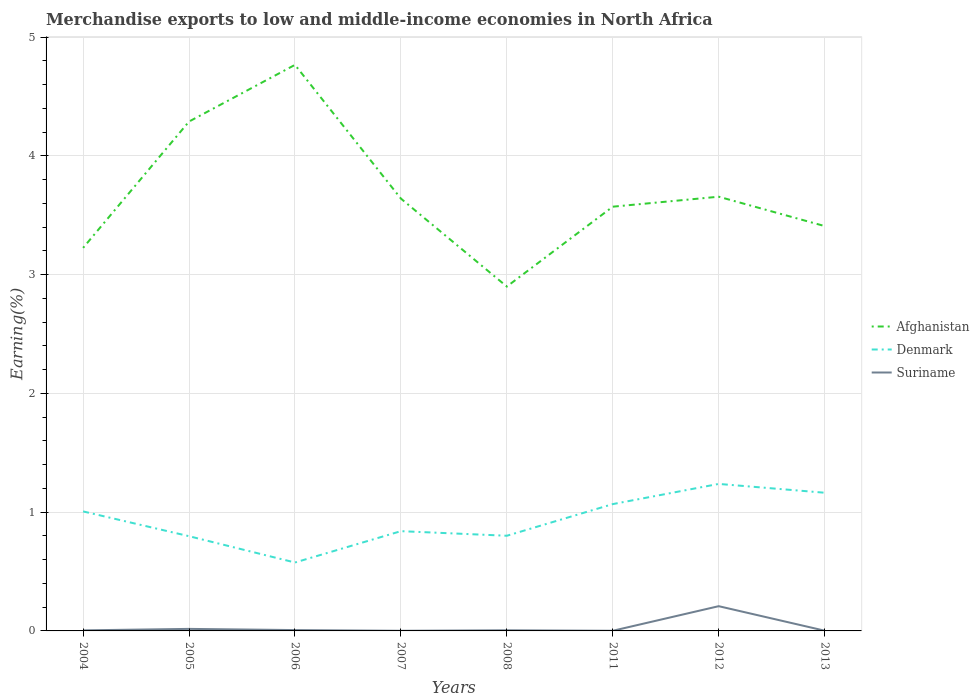Does the line corresponding to Denmark intersect with the line corresponding to Afghanistan?
Your answer should be compact. No. Is the number of lines equal to the number of legend labels?
Your answer should be very brief. Yes. Across all years, what is the maximum percentage of amount earned from merchandise exports in Suriname?
Make the answer very short. 0. In which year was the percentage of amount earned from merchandise exports in Suriname maximum?
Keep it short and to the point. 2007. What is the total percentage of amount earned from merchandise exports in Suriname in the graph?
Ensure brevity in your answer.  -0.2. What is the difference between the highest and the second highest percentage of amount earned from merchandise exports in Afghanistan?
Keep it short and to the point. 1.87. What is the difference between the highest and the lowest percentage of amount earned from merchandise exports in Suriname?
Your response must be concise. 1. How many years are there in the graph?
Ensure brevity in your answer.  8. Does the graph contain grids?
Your answer should be very brief. Yes. Where does the legend appear in the graph?
Your answer should be compact. Center right. How many legend labels are there?
Your answer should be very brief. 3. What is the title of the graph?
Provide a succinct answer. Merchandise exports to low and middle-income economies in North Africa. What is the label or title of the X-axis?
Your response must be concise. Years. What is the label or title of the Y-axis?
Offer a very short reply. Earning(%). What is the Earning(%) in Afghanistan in 2004?
Give a very brief answer. 3.23. What is the Earning(%) in Denmark in 2004?
Provide a succinct answer. 1.01. What is the Earning(%) in Suriname in 2004?
Provide a short and direct response. 0. What is the Earning(%) of Afghanistan in 2005?
Offer a very short reply. 4.29. What is the Earning(%) of Denmark in 2005?
Offer a very short reply. 0.8. What is the Earning(%) in Suriname in 2005?
Your answer should be very brief. 0.02. What is the Earning(%) of Afghanistan in 2006?
Offer a very short reply. 4.77. What is the Earning(%) of Denmark in 2006?
Give a very brief answer. 0.58. What is the Earning(%) in Suriname in 2006?
Your response must be concise. 0.01. What is the Earning(%) of Afghanistan in 2007?
Provide a short and direct response. 3.64. What is the Earning(%) of Denmark in 2007?
Provide a short and direct response. 0.84. What is the Earning(%) in Suriname in 2007?
Give a very brief answer. 0. What is the Earning(%) of Afghanistan in 2008?
Make the answer very short. 2.9. What is the Earning(%) in Denmark in 2008?
Give a very brief answer. 0.8. What is the Earning(%) in Suriname in 2008?
Keep it short and to the point. 0.01. What is the Earning(%) of Afghanistan in 2011?
Give a very brief answer. 3.57. What is the Earning(%) of Denmark in 2011?
Make the answer very short. 1.07. What is the Earning(%) of Suriname in 2011?
Your response must be concise. 0. What is the Earning(%) of Afghanistan in 2012?
Your answer should be compact. 3.66. What is the Earning(%) in Denmark in 2012?
Make the answer very short. 1.24. What is the Earning(%) of Suriname in 2012?
Your answer should be compact. 0.21. What is the Earning(%) in Afghanistan in 2013?
Your answer should be compact. 3.41. What is the Earning(%) in Denmark in 2013?
Ensure brevity in your answer.  1.16. What is the Earning(%) of Suriname in 2013?
Provide a short and direct response. 0. Across all years, what is the maximum Earning(%) in Afghanistan?
Ensure brevity in your answer.  4.77. Across all years, what is the maximum Earning(%) of Denmark?
Keep it short and to the point. 1.24. Across all years, what is the maximum Earning(%) in Suriname?
Provide a succinct answer. 0.21. Across all years, what is the minimum Earning(%) of Afghanistan?
Ensure brevity in your answer.  2.9. Across all years, what is the minimum Earning(%) of Denmark?
Your response must be concise. 0.58. Across all years, what is the minimum Earning(%) in Suriname?
Provide a succinct answer. 0. What is the total Earning(%) in Afghanistan in the graph?
Your response must be concise. 29.46. What is the total Earning(%) of Denmark in the graph?
Offer a very short reply. 7.49. What is the total Earning(%) of Suriname in the graph?
Give a very brief answer. 0.25. What is the difference between the Earning(%) of Afghanistan in 2004 and that in 2005?
Your response must be concise. -1.06. What is the difference between the Earning(%) in Denmark in 2004 and that in 2005?
Ensure brevity in your answer.  0.21. What is the difference between the Earning(%) in Suriname in 2004 and that in 2005?
Offer a very short reply. -0.01. What is the difference between the Earning(%) of Afghanistan in 2004 and that in 2006?
Provide a succinct answer. -1.54. What is the difference between the Earning(%) in Denmark in 2004 and that in 2006?
Your answer should be compact. 0.43. What is the difference between the Earning(%) of Suriname in 2004 and that in 2006?
Provide a short and direct response. -0. What is the difference between the Earning(%) in Afghanistan in 2004 and that in 2007?
Provide a succinct answer. -0.41. What is the difference between the Earning(%) of Denmark in 2004 and that in 2007?
Your answer should be compact. 0.17. What is the difference between the Earning(%) of Suriname in 2004 and that in 2007?
Keep it short and to the point. 0. What is the difference between the Earning(%) in Afghanistan in 2004 and that in 2008?
Make the answer very short. 0.33. What is the difference between the Earning(%) of Denmark in 2004 and that in 2008?
Offer a very short reply. 0.2. What is the difference between the Earning(%) in Suriname in 2004 and that in 2008?
Ensure brevity in your answer.  -0. What is the difference between the Earning(%) of Afghanistan in 2004 and that in 2011?
Your answer should be compact. -0.35. What is the difference between the Earning(%) of Denmark in 2004 and that in 2011?
Keep it short and to the point. -0.06. What is the difference between the Earning(%) in Suriname in 2004 and that in 2011?
Make the answer very short. 0. What is the difference between the Earning(%) in Afghanistan in 2004 and that in 2012?
Offer a very short reply. -0.43. What is the difference between the Earning(%) in Denmark in 2004 and that in 2012?
Give a very brief answer. -0.23. What is the difference between the Earning(%) in Suriname in 2004 and that in 2012?
Provide a short and direct response. -0.2. What is the difference between the Earning(%) of Afghanistan in 2004 and that in 2013?
Make the answer very short. -0.18. What is the difference between the Earning(%) of Denmark in 2004 and that in 2013?
Provide a succinct answer. -0.16. What is the difference between the Earning(%) of Suriname in 2004 and that in 2013?
Make the answer very short. 0. What is the difference between the Earning(%) in Afghanistan in 2005 and that in 2006?
Provide a short and direct response. -0.48. What is the difference between the Earning(%) in Denmark in 2005 and that in 2006?
Your answer should be compact. 0.22. What is the difference between the Earning(%) in Suriname in 2005 and that in 2006?
Make the answer very short. 0.01. What is the difference between the Earning(%) in Afghanistan in 2005 and that in 2007?
Offer a very short reply. 0.65. What is the difference between the Earning(%) in Denmark in 2005 and that in 2007?
Ensure brevity in your answer.  -0.04. What is the difference between the Earning(%) of Suriname in 2005 and that in 2007?
Give a very brief answer. 0.02. What is the difference between the Earning(%) of Afghanistan in 2005 and that in 2008?
Offer a very short reply. 1.39. What is the difference between the Earning(%) in Denmark in 2005 and that in 2008?
Provide a short and direct response. -0. What is the difference between the Earning(%) of Suriname in 2005 and that in 2008?
Keep it short and to the point. 0.01. What is the difference between the Earning(%) in Afghanistan in 2005 and that in 2011?
Your answer should be compact. 0.72. What is the difference between the Earning(%) in Denmark in 2005 and that in 2011?
Keep it short and to the point. -0.27. What is the difference between the Earning(%) in Suriname in 2005 and that in 2011?
Provide a succinct answer. 0.02. What is the difference between the Earning(%) in Afghanistan in 2005 and that in 2012?
Offer a terse response. 0.63. What is the difference between the Earning(%) of Denmark in 2005 and that in 2012?
Your response must be concise. -0.44. What is the difference between the Earning(%) of Suriname in 2005 and that in 2012?
Offer a terse response. -0.19. What is the difference between the Earning(%) in Afghanistan in 2005 and that in 2013?
Provide a short and direct response. 0.88. What is the difference between the Earning(%) in Denmark in 2005 and that in 2013?
Your answer should be compact. -0.37. What is the difference between the Earning(%) in Suriname in 2005 and that in 2013?
Ensure brevity in your answer.  0.01. What is the difference between the Earning(%) in Afghanistan in 2006 and that in 2007?
Provide a short and direct response. 1.13. What is the difference between the Earning(%) in Denmark in 2006 and that in 2007?
Give a very brief answer. -0.26. What is the difference between the Earning(%) in Suriname in 2006 and that in 2007?
Give a very brief answer. 0.01. What is the difference between the Earning(%) of Afghanistan in 2006 and that in 2008?
Keep it short and to the point. 1.87. What is the difference between the Earning(%) in Denmark in 2006 and that in 2008?
Ensure brevity in your answer.  -0.23. What is the difference between the Earning(%) of Suriname in 2006 and that in 2008?
Provide a short and direct response. 0. What is the difference between the Earning(%) in Afghanistan in 2006 and that in 2011?
Offer a very short reply. 1.19. What is the difference between the Earning(%) of Denmark in 2006 and that in 2011?
Provide a short and direct response. -0.49. What is the difference between the Earning(%) in Suriname in 2006 and that in 2011?
Ensure brevity in your answer.  0.01. What is the difference between the Earning(%) of Afghanistan in 2006 and that in 2012?
Your response must be concise. 1.11. What is the difference between the Earning(%) of Denmark in 2006 and that in 2012?
Give a very brief answer. -0.66. What is the difference between the Earning(%) of Suriname in 2006 and that in 2012?
Ensure brevity in your answer.  -0.2. What is the difference between the Earning(%) of Afghanistan in 2006 and that in 2013?
Offer a very short reply. 1.36. What is the difference between the Earning(%) of Denmark in 2006 and that in 2013?
Ensure brevity in your answer.  -0.59. What is the difference between the Earning(%) in Suriname in 2006 and that in 2013?
Provide a succinct answer. 0.01. What is the difference between the Earning(%) in Afghanistan in 2007 and that in 2008?
Offer a terse response. 0.74. What is the difference between the Earning(%) of Denmark in 2007 and that in 2008?
Give a very brief answer. 0.04. What is the difference between the Earning(%) in Suriname in 2007 and that in 2008?
Keep it short and to the point. -0. What is the difference between the Earning(%) of Afghanistan in 2007 and that in 2011?
Offer a terse response. 0.07. What is the difference between the Earning(%) in Denmark in 2007 and that in 2011?
Your answer should be very brief. -0.23. What is the difference between the Earning(%) in Suriname in 2007 and that in 2011?
Provide a short and direct response. -0. What is the difference between the Earning(%) of Afghanistan in 2007 and that in 2012?
Your answer should be compact. -0.02. What is the difference between the Earning(%) in Denmark in 2007 and that in 2012?
Keep it short and to the point. -0.4. What is the difference between the Earning(%) of Suriname in 2007 and that in 2012?
Make the answer very short. -0.21. What is the difference between the Earning(%) in Afghanistan in 2007 and that in 2013?
Offer a terse response. 0.23. What is the difference between the Earning(%) of Denmark in 2007 and that in 2013?
Provide a short and direct response. -0.32. What is the difference between the Earning(%) of Suriname in 2007 and that in 2013?
Ensure brevity in your answer.  -0. What is the difference between the Earning(%) in Afghanistan in 2008 and that in 2011?
Offer a terse response. -0.67. What is the difference between the Earning(%) in Denmark in 2008 and that in 2011?
Offer a terse response. -0.27. What is the difference between the Earning(%) of Suriname in 2008 and that in 2011?
Your answer should be very brief. 0. What is the difference between the Earning(%) of Afghanistan in 2008 and that in 2012?
Offer a very short reply. -0.76. What is the difference between the Earning(%) in Denmark in 2008 and that in 2012?
Offer a very short reply. -0.44. What is the difference between the Earning(%) in Suriname in 2008 and that in 2012?
Give a very brief answer. -0.2. What is the difference between the Earning(%) of Afghanistan in 2008 and that in 2013?
Your answer should be very brief. -0.51. What is the difference between the Earning(%) in Denmark in 2008 and that in 2013?
Offer a very short reply. -0.36. What is the difference between the Earning(%) in Suriname in 2008 and that in 2013?
Make the answer very short. 0. What is the difference between the Earning(%) of Afghanistan in 2011 and that in 2012?
Give a very brief answer. -0.08. What is the difference between the Earning(%) of Denmark in 2011 and that in 2012?
Your response must be concise. -0.17. What is the difference between the Earning(%) of Suriname in 2011 and that in 2012?
Ensure brevity in your answer.  -0.21. What is the difference between the Earning(%) in Afghanistan in 2011 and that in 2013?
Offer a terse response. 0.16. What is the difference between the Earning(%) of Denmark in 2011 and that in 2013?
Ensure brevity in your answer.  -0.1. What is the difference between the Earning(%) in Suriname in 2011 and that in 2013?
Offer a very short reply. -0. What is the difference between the Earning(%) of Afghanistan in 2012 and that in 2013?
Your answer should be very brief. 0.25. What is the difference between the Earning(%) of Denmark in 2012 and that in 2013?
Ensure brevity in your answer.  0.07. What is the difference between the Earning(%) in Suriname in 2012 and that in 2013?
Give a very brief answer. 0.21. What is the difference between the Earning(%) of Afghanistan in 2004 and the Earning(%) of Denmark in 2005?
Offer a terse response. 2.43. What is the difference between the Earning(%) in Afghanistan in 2004 and the Earning(%) in Suriname in 2005?
Your response must be concise. 3.21. What is the difference between the Earning(%) in Afghanistan in 2004 and the Earning(%) in Denmark in 2006?
Your answer should be compact. 2.65. What is the difference between the Earning(%) of Afghanistan in 2004 and the Earning(%) of Suriname in 2006?
Your answer should be compact. 3.22. What is the difference between the Earning(%) of Afghanistan in 2004 and the Earning(%) of Denmark in 2007?
Offer a terse response. 2.39. What is the difference between the Earning(%) in Afghanistan in 2004 and the Earning(%) in Suriname in 2007?
Provide a succinct answer. 3.22. What is the difference between the Earning(%) of Denmark in 2004 and the Earning(%) of Suriname in 2007?
Your answer should be very brief. 1.01. What is the difference between the Earning(%) of Afghanistan in 2004 and the Earning(%) of Denmark in 2008?
Offer a terse response. 2.42. What is the difference between the Earning(%) in Afghanistan in 2004 and the Earning(%) in Suriname in 2008?
Make the answer very short. 3.22. What is the difference between the Earning(%) of Denmark in 2004 and the Earning(%) of Suriname in 2008?
Give a very brief answer. 1. What is the difference between the Earning(%) of Afghanistan in 2004 and the Earning(%) of Denmark in 2011?
Your answer should be very brief. 2.16. What is the difference between the Earning(%) of Afghanistan in 2004 and the Earning(%) of Suriname in 2011?
Your answer should be compact. 3.22. What is the difference between the Earning(%) in Denmark in 2004 and the Earning(%) in Suriname in 2011?
Provide a succinct answer. 1. What is the difference between the Earning(%) of Afghanistan in 2004 and the Earning(%) of Denmark in 2012?
Provide a succinct answer. 1.99. What is the difference between the Earning(%) of Afghanistan in 2004 and the Earning(%) of Suriname in 2012?
Ensure brevity in your answer.  3.02. What is the difference between the Earning(%) of Denmark in 2004 and the Earning(%) of Suriname in 2012?
Offer a terse response. 0.8. What is the difference between the Earning(%) of Afghanistan in 2004 and the Earning(%) of Denmark in 2013?
Provide a short and direct response. 2.06. What is the difference between the Earning(%) of Afghanistan in 2004 and the Earning(%) of Suriname in 2013?
Your answer should be compact. 3.22. What is the difference between the Earning(%) of Denmark in 2004 and the Earning(%) of Suriname in 2013?
Your response must be concise. 1. What is the difference between the Earning(%) in Afghanistan in 2005 and the Earning(%) in Denmark in 2006?
Offer a terse response. 3.71. What is the difference between the Earning(%) in Afghanistan in 2005 and the Earning(%) in Suriname in 2006?
Make the answer very short. 4.28. What is the difference between the Earning(%) in Denmark in 2005 and the Earning(%) in Suriname in 2006?
Offer a very short reply. 0.79. What is the difference between the Earning(%) in Afghanistan in 2005 and the Earning(%) in Denmark in 2007?
Your answer should be compact. 3.45. What is the difference between the Earning(%) of Afghanistan in 2005 and the Earning(%) of Suriname in 2007?
Provide a succinct answer. 4.29. What is the difference between the Earning(%) in Denmark in 2005 and the Earning(%) in Suriname in 2007?
Ensure brevity in your answer.  0.8. What is the difference between the Earning(%) of Afghanistan in 2005 and the Earning(%) of Denmark in 2008?
Offer a terse response. 3.49. What is the difference between the Earning(%) of Afghanistan in 2005 and the Earning(%) of Suriname in 2008?
Your answer should be compact. 4.28. What is the difference between the Earning(%) of Denmark in 2005 and the Earning(%) of Suriname in 2008?
Your answer should be very brief. 0.79. What is the difference between the Earning(%) of Afghanistan in 2005 and the Earning(%) of Denmark in 2011?
Give a very brief answer. 3.22. What is the difference between the Earning(%) of Afghanistan in 2005 and the Earning(%) of Suriname in 2011?
Your answer should be compact. 4.29. What is the difference between the Earning(%) in Denmark in 2005 and the Earning(%) in Suriname in 2011?
Provide a short and direct response. 0.8. What is the difference between the Earning(%) of Afghanistan in 2005 and the Earning(%) of Denmark in 2012?
Offer a very short reply. 3.05. What is the difference between the Earning(%) of Afghanistan in 2005 and the Earning(%) of Suriname in 2012?
Keep it short and to the point. 4.08. What is the difference between the Earning(%) in Denmark in 2005 and the Earning(%) in Suriname in 2012?
Ensure brevity in your answer.  0.59. What is the difference between the Earning(%) of Afghanistan in 2005 and the Earning(%) of Denmark in 2013?
Your answer should be very brief. 3.13. What is the difference between the Earning(%) of Afghanistan in 2005 and the Earning(%) of Suriname in 2013?
Give a very brief answer. 4.29. What is the difference between the Earning(%) in Denmark in 2005 and the Earning(%) in Suriname in 2013?
Offer a very short reply. 0.8. What is the difference between the Earning(%) of Afghanistan in 2006 and the Earning(%) of Denmark in 2007?
Your answer should be very brief. 3.93. What is the difference between the Earning(%) in Afghanistan in 2006 and the Earning(%) in Suriname in 2007?
Keep it short and to the point. 4.76. What is the difference between the Earning(%) of Denmark in 2006 and the Earning(%) of Suriname in 2007?
Your response must be concise. 0.57. What is the difference between the Earning(%) in Afghanistan in 2006 and the Earning(%) in Denmark in 2008?
Provide a succinct answer. 3.96. What is the difference between the Earning(%) of Afghanistan in 2006 and the Earning(%) of Suriname in 2008?
Your answer should be very brief. 4.76. What is the difference between the Earning(%) in Denmark in 2006 and the Earning(%) in Suriname in 2008?
Your response must be concise. 0.57. What is the difference between the Earning(%) in Afghanistan in 2006 and the Earning(%) in Denmark in 2011?
Your answer should be compact. 3.7. What is the difference between the Earning(%) in Afghanistan in 2006 and the Earning(%) in Suriname in 2011?
Your answer should be very brief. 4.76. What is the difference between the Earning(%) of Denmark in 2006 and the Earning(%) of Suriname in 2011?
Provide a short and direct response. 0.57. What is the difference between the Earning(%) of Afghanistan in 2006 and the Earning(%) of Denmark in 2012?
Offer a terse response. 3.53. What is the difference between the Earning(%) in Afghanistan in 2006 and the Earning(%) in Suriname in 2012?
Make the answer very short. 4.56. What is the difference between the Earning(%) of Denmark in 2006 and the Earning(%) of Suriname in 2012?
Give a very brief answer. 0.37. What is the difference between the Earning(%) in Afghanistan in 2006 and the Earning(%) in Denmark in 2013?
Your response must be concise. 3.6. What is the difference between the Earning(%) of Afghanistan in 2006 and the Earning(%) of Suriname in 2013?
Your answer should be very brief. 4.76. What is the difference between the Earning(%) of Denmark in 2006 and the Earning(%) of Suriname in 2013?
Give a very brief answer. 0.57. What is the difference between the Earning(%) in Afghanistan in 2007 and the Earning(%) in Denmark in 2008?
Your response must be concise. 2.84. What is the difference between the Earning(%) of Afghanistan in 2007 and the Earning(%) of Suriname in 2008?
Make the answer very short. 3.63. What is the difference between the Earning(%) in Denmark in 2007 and the Earning(%) in Suriname in 2008?
Provide a short and direct response. 0.83. What is the difference between the Earning(%) in Afghanistan in 2007 and the Earning(%) in Denmark in 2011?
Your response must be concise. 2.57. What is the difference between the Earning(%) in Afghanistan in 2007 and the Earning(%) in Suriname in 2011?
Your answer should be compact. 3.64. What is the difference between the Earning(%) of Denmark in 2007 and the Earning(%) of Suriname in 2011?
Your answer should be compact. 0.84. What is the difference between the Earning(%) in Afghanistan in 2007 and the Earning(%) in Denmark in 2012?
Your answer should be compact. 2.4. What is the difference between the Earning(%) in Afghanistan in 2007 and the Earning(%) in Suriname in 2012?
Ensure brevity in your answer.  3.43. What is the difference between the Earning(%) of Denmark in 2007 and the Earning(%) of Suriname in 2012?
Give a very brief answer. 0.63. What is the difference between the Earning(%) of Afghanistan in 2007 and the Earning(%) of Denmark in 2013?
Keep it short and to the point. 2.48. What is the difference between the Earning(%) of Afghanistan in 2007 and the Earning(%) of Suriname in 2013?
Make the answer very short. 3.64. What is the difference between the Earning(%) of Denmark in 2007 and the Earning(%) of Suriname in 2013?
Offer a very short reply. 0.84. What is the difference between the Earning(%) of Afghanistan in 2008 and the Earning(%) of Denmark in 2011?
Ensure brevity in your answer.  1.83. What is the difference between the Earning(%) of Afghanistan in 2008 and the Earning(%) of Suriname in 2011?
Provide a succinct answer. 2.9. What is the difference between the Earning(%) in Denmark in 2008 and the Earning(%) in Suriname in 2011?
Your answer should be compact. 0.8. What is the difference between the Earning(%) of Afghanistan in 2008 and the Earning(%) of Denmark in 2012?
Your answer should be compact. 1.66. What is the difference between the Earning(%) in Afghanistan in 2008 and the Earning(%) in Suriname in 2012?
Your answer should be compact. 2.69. What is the difference between the Earning(%) in Denmark in 2008 and the Earning(%) in Suriname in 2012?
Offer a terse response. 0.59. What is the difference between the Earning(%) in Afghanistan in 2008 and the Earning(%) in Denmark in 2013?
Offer a terse response. 1.74. What is the difference between the Earning(%) in Afghanistan in 2008 and the Earning(%) in Suriname in 2013?
Your answer should be compact. 2.9. What is the difference between the Earning(%) in Denmark in 2008 and the Earning(%) in Suriname in 2013?
Keep it short and to the point. 0.8. What is the difference between the Earning(%) of Afghanistan in 2011 and the Earning(%) of Denmark in 2012?
Ensure brevity in your answer.  2.33. What is the difference between the Earning(%) in Afghanistan in 2011 and the Earning(%) in Suriname in 2012?
Offer a terse response. 3.36. What is the difference between the Earning(%) in Denmark in 2011 and the Earning(%) in Suriname in 2012?
Your answer should be very brief. 0.86. What is the difference between the Earning(%) in Afghanistan in 2011 and the Earning(%) in Denmark in 2013?
Make the answer very short. 2.41. What is the difference between the Earning(%) in Afghanistan in 2011 and the Earning(%) in Suriname in 2013?
Your answer should be very brief. 3.57. What is the difference between the Earning(%) in Denmark in 2011 and the Earning(%) in Suriname in 2013?
Give a very brief answer. 1.07. What is the difference between the Earning(%) of Afghanistan in 2012 and the Earning(%) of Denmark in 2013?
Make the answer very short. 2.49. What is the difference between the Earning(%) of Afghanistan in 2012 and the Earning(%) of Suriname in 2013?
Make the answer very short. 3.65. What is the difference between the Earning(%) of Denmark in 2012 and the Earning(%) of Suriname in 2013?
Provide a short and direct response. 1.24. What is the average Earning(%) of Afghanistan per year?
Offer a terse response. 3.68. What is the average Earning(%) of Denmark per year?
Ensure brevity in your answer.  0.94. What is the average Earning(%) in Suriname per year?
Provide a short and direct response. 0.03. In the year 2004, what is the difference between the Earning(%) of Afghanistan and Earning(%) of Denmark?
Your answer should be very brief. 2.22. In the year 2004, what is the difference between the Earning(%) in Afghanistan and Earning(%) in Suriname?
Offer a very short reply. 3.22. In the year 2005, what is the difference between the Earning(%) of Afghanistan and Earning(%) of Denmark?
Ensure brevity in your answer.  3.49. In the year 2005, what is the difference between the Earning(%) in Afghanistan and Earning(%) in Suriname?
Keep it short and to the point. 4.27. In the year 2005, what is the difference between the Earning(%) of Denmark and Earning(%) of Suriname?
Offer a terse response. 0.78. In the year 2006, what is the difference between the Earning(%) of Afghanistan and Earning(%) of Denmark?
Keep it short and to the point. 4.19. In the year 2006, what is the difference between the Earning(%) in Afghanistan and Earning(%) in Suriname?
Your response must be concise. 4.76. In the year 2006, what is the difference between the Earning(%) of Denmark and Earning(%) of Suriname?
Make the answer very short. 0.57. In the year 2007, what is the difference between the Earning(%) in Afghanistan and Earning(%) in Denmark?
Your answer should be compact. 2.8. In the year 2007, what is the difference between the Earning(%) of Afghanistan and Earning(%) of Suriname?
Your answer should be very brief. 3.64. In the year 2007, what is the difference between the Earning(%) in Denmark and Earning(%) in Suriname?
Your answer should be very brief. 0.84. In the year 2008, what is the difference between the Earning(%) of Afghanistan and Earning(%) of Denmark?
Give a very brief answer. 2.1. In the year 2008, what is the difference between the Earning(%) of Afghanistan and Earning(%) of Suriname?
Offer a very short reply. 2.89. In the year 2008, what is the difference between the Earning(%) of Denmark and Earning(%) of Suriname?
Offer a very short reply. 0.8. In the year 2011, what is the difference between the Earning(%) in Afghanistan and Earning(%) in Denmark?
Ensure brevity in your answer.  2.5. In the year 2011, what is the difference between the Earning(%) of Afghanistan and Earning(%) of Suriname?
Your answer should be very brief. 3.57. In the year 2011, what is the difference between the Earning(%) of Denmark and Earning(%) of Suriname?
Your response must be concise. 1.07. In the year 2012, what is the difference between the Earning(%) of Afghanistan and Earning(%) of Denmark?
Ensure brevity in your answer.  2.42. In the year 2012, what is the difference between the Earning(%) in Afghanistan and Earning(%) in Suriname?
Provide a succinct answer. 3.45. In the year 2012, what is the difference between the Earning(%) of Denmark and Earning(%) of Suriname?
Make the answer very short. 1.03. In the year 2013, what is the difference between the Earning(%) in Afghanistan and Earning(%) in Denmark?
Your answer should be compact. 2.25. In the year 2013, what is the difference between the Earning(%) in Afghanistan and Earning(%) in Suriname?
Provide a short and direct response. 3.41. In the year 2013, what is the difference between the Earning(%) of Denmark and Earning(%) of Suriname?
Your answer should be very brief. 1.16. What is the ratio of the Earning(%) of Afghanistan in 2004 to that in 2005?
Offer a terse response. 0.75. What is the ratio of the Earning(%) of Denmark in 2004 to that in 2005?
Ensure brevity in your answer.  1.26. What is the ratio of the Earning(%) of Suriname in 2004 to that in 2005?
Offer a very short reply. 0.27. What is the ratio of the Earning(%) in Afghanistan in 2004 to that in 2006?
Keep it short and to the point. 0.68. What is the ratio of the Earning(%) of Denmark in 2004 to that in 2006?
Your answer should be compact. 1.75. What is the ratio of the Earning(%) of Suriname in 2004 to that in 2006?
Make the answer very short. 0.66. What is the ratio of the Earning(%) in Afghanistan in 2004 to that in 2007?
Provide a short and direct response. 0.89. What is the ratio of the Earning(%) in Denmark in 2004 to that in 2007?
Offer a very short reply. 1.2. What is the ratio of the Earning(%) of Suriname in 2004 to that in 2007?
Provide a short and direct response. 4.11. What is the ratio of the Earning(%) of Afghanistan in 2004 to that in 2008?
Provide a succinct answer. 1.11. What is the ratio of the Earning(%) of Denmark in 2004 to that in 2008?
Make the answer very short. 1.26. What is the ratio of the Earning(%) in Suriname in 2004 to that in 2008?
Provide a succinct answer. 0.87. What is the ratio of the Earning(%) of Afghanistan in 2004 to that in 2011?
Your answer should be compact. 0.9. What is the ratio of the Earning(%) in Denmark in 2004 to that in 2011?
Offer a terse response. 0.94. What is the ratio of the Earning(%) in Suriname in 2004 to that in 2011?
Ensure brevity in your answer.  3.74. What is the ratio of the Earning(%) of Afghanistan in 2004 to that in 2012?
Provide a succinct answer. 0.88. What is the ratio of the Earning(%) in Denmark in 2004 to that in 2012?
Ensure brevity in your answer.  0.81. What is the ratio of the Earning(%) in Suriname in 2004 to that in 2012?
Provide a succinct answer. 0.02. What is the ratio of the Earning(%) of Afghanistan in 2004 to that in 2013?
Offer a terse response. 0.95. What is the ratio of the Earning(%) of Denmark in 2004 to that in 2013?
Provide a short and direct response. 0.86. What is the ratio of the Earning(%) in Suriname in 2004 to that in 2013?
Offer a very short reply. 2.22. What is the ratio of the Earning(%) in Afghanistan in 2005 to that in 2006?
Your answer should be very brief. 0.9. What is the ratio of the Earning(%) of Denmark in 2005 to that in 2006?
Provide a short and direct response. 1.38. What is the ratio of the Earning(%) in Suriname in 2005 to that in 2006?
Offer a terse response. 2.43. What is the ratio of the Earning(%) of Afghanistan in 2005 to that in 2007?
Give a very brief answer. 1.18. What is the ratio of the Earning(%) in Denmark in 2005 to that in 2007?
Ensure brevity in your answer.  0.95. What is the ratio of the Earning(%) in Suriname in 2005 to that in 2007?
Provide a short and direct response. 15.05. What is the ratio of the Earning(%) in Afghanistan in 2005 to that in 2008?
Give a very brief answer. 1.48. What is the ratio of the Earning(%) in Denmark in 2005 to that in 2008?
Offer a terse response. 1. What is the ratio of the Earning(%) in Suriname in 2005 to that in 2008?
Give a very brief answer. 3.19. What is the ratio of the Earning(%) in Afghanistan in 2005 to that in 2011?
Your answer should be very brief. 1.2. What is the ratio of the Earning(%) of Denmark in 2005 to that in 2011?
Your answer should be compact. 0.75. What is the ratio of the Earning(%) of Suriname in 2005 to that in 2011?
Your answer should be compact. 13.7. What is the ratio of the Earning(%) of Afghanistan in 2005 to that in 2012?
Make the answer very short. 1.17. What is the ratio of the Earning(%) in Denmark in 2005 to that in 2012?
Your answer should be compact. 0.64. What is the ratio of the Earning(%) in Suriname in 2005 to that in 2012?
Offer a very short reply. 0.08. What is the ratio of the Earning(%) of Afghanistan in 2005 to that in 2013?
Offer a very short reply. 1.26. What is the ratio of the Earning(%) in Denmark in 2005 to that in 2013?
Provide a short and direct response. 0.69. What is the ratio of the Earning(%) of Suriname in 2005 to that in 2013?
Make the answer very short. 8.13. What is the ratio of the Earning(%) of Afghanistan in 2006 to that in 2007?
Offer a very short reply. 1.31. What is the ratio of the Earning(%) in Denmark in 2006 to that in 2007?
Give a very brief answer. 0.69. What is the ratio of the Earning(%) of Suriname in 2006 to that in 2007?
Your answer should be very brief. 6.2. What is the ratio of the Earning(%) of Afghanistan in 2006 to that in 2008?
Your response must be concise. 1.64. What is the ratio of the Earning(%) of Denmark in 2006 to that in 2008?
Give a very brief answer. 0.72. What is the ratio of the Earning(%) in Suriname in 2006 to that in 2008?
Ensure brevity in your answer.  1.32. What is the ratio of the Earning(%) in Afghanistan in 2006 to that in 2011?
Your response must be concise. 1.33. What is the ratio of the Earning(%) of Denmark in 2006 to that in 2011?
Provide a short and direct response. 0.54. What is the ratio of the Earning(%) of Suriname in 2006 to that in 2011?
Ensure brevity in your answer.  5.65. What is the ratio of the Earning(%) of Afghanistan in 2006 to that in 2012?
Keep it short and to the point. 1.3. What is the ratio of the Earning(%) of Denmark in 2006 to that in 2012?
Provide a short and direct response. 0.47. What is the ratio of the Earning(%) in Suriname in 2006 to that in 2012?
Give a very brief answer. 0.03. What is the ratio of the Earning(%) in Afghanistan in 2006 to that in 2013?
Provide a succinct answer. 1.4. What is the ratio of the Earning(%) in Denmark in 2006 to that in 2013?
Keep it short and to the point. 0.5. What is the ratio of the Earning(%) of Suriname in 2006 to that in 2013?
Your response must be concise. 3.35. What is the ratio of the Earning(%) of Afghanistan in 2007 to that in 2008?
Offer a terse response. 1.26. What is the ratio of the Earning(%) in Denmark in 2007 to that in 2008?
Ensure brevity in your answer.  1.05. What is the ratio of the Earning(%) of Suriname in 2007 to that in 2008?
Keep it short and to the point. 0.21. What is the ratio of the Earning(%) in Afghanistan in 2007 to that in 2011?
Offer a very short reply. 1.02. What is the ratio of the Earning(%) of Denmark in 2007 to that in 2011?
Ensure brevity in your answer.  0.79. What is the ratio of the Earning(%) of Suriname in 2007 to that in 2011?
Offer a very short reply. 0.91. What is the ratio of the Earning(%) in Denmark in 2007 to that in 2012?
Provide a succinct answer. 0.68. What is the ratio of the Earning(%) in Suriname in 2007 to that in 2012?
Make the answer very short. 0.01. What is the ratio of the Earning(%) in Afghanistan in 2007 to that in 2013?
Offer a very short reply. 1.07. What is the ratio of the Earning(%) of Denmark in 2007 to that in 2013?
Your answer should be compact. 0.72. What is the ratio of the Earning(%) of Suriname in 2007 to that in 2013?
Keep it short and to the point. 0.54. What is the ratio of the Earning(%) in Afghanistan in 2008 to that in 2011?
Make the answer very short. 0.81. What is the ratio of the Earning(%) of Denmark in 2008 to that in 2011?
Offer a terse response. 0.75. What is the ratio of the Earning(%) in Suriname in 2008 to that in 2011?
Offer a very short reply. 4.3. What is the ratio of the Earning(%) of Afghanistan in 2008 to that in 2012?
Make the answer very short. 0.79. What is the ratio of the Earning(%) of Denmark in 2008 to that in 2012?
Keep it short and to the point. 0.65. What is the ratio of the Earning(%) of Suriname in 2008 to that in 2012?
Give a very brief answer. 0.03. What is the ratio of the Earning(%) in Afghanistan in 2008 to that in 2013?
Make the answer very short. 0.85. What is the ratio of the Earning(%) of Denmark in 2008 to that in 2013?
Provide a succinct answer. 0.69. What is the ratio of the Earning(%) in Suriname in 2008 to that in 2013?
Provide a succinct answer. 2.55. What is the ratio of the Earning(%) of Afghanistan in 2011 to that in 2012?
Provide a succinct answer. 0.98. What is the ratio of the Earning(%) in Denmark in 2011 to that in 2012?
Provide a succinct answer. 0.86. What is the ratio of the Earning(%) of Suriname in 2011 to that in 2012?
Your answer should be very brief. 0.01. What is the ratio of the Earning(%) in Afghanistan in 2011 to that in 2013?
Give a very brief answer. 1.05. What is the ratio of the Earning(%) in Denmark in 2011 to that in 2013?
Keep it short and to the point. 0.92. What is the ratio of the Earning(%) of Suriname in 2011 to that in 2013?
Your answer should be compact. 0.59. What is the ratio of the Earning(%) of Afghanistan in 2012 to that in 2013?
Your answer should be very brief. 1.07. What is the ratio of the Earning(%) of Denmark in 2012 to that in 2013?
Provide a short and direct response. 1.06. What is the ratio of the Earning(%) in Suriname in 2012 to that in 2013?
Your answer should be very brief. 98.75. What is the difference between the highest and the second highest Earning(%) in Afghanistan?
Your response must be concise. 0.48. What is the difference between the highest and the second highest Earning(%) of Denmark?
Provide a short and direct response. 0.07. What is the difference between the highest and the second highest Earning(%) of Suriname?
Provide a short and direct response. 0.19. What is the difference between the highest and the lowest Earning(%) in Afghanistan?
Your answer should be very brief. 1.87. What is the difference between the highest and the lowest Earning(%) in Denmark?
Give a very brief answer. 0.66. What is the difference between the highest and the lowest Earning(%) of Suriname?
Your answer should be very brief. 0.21. 